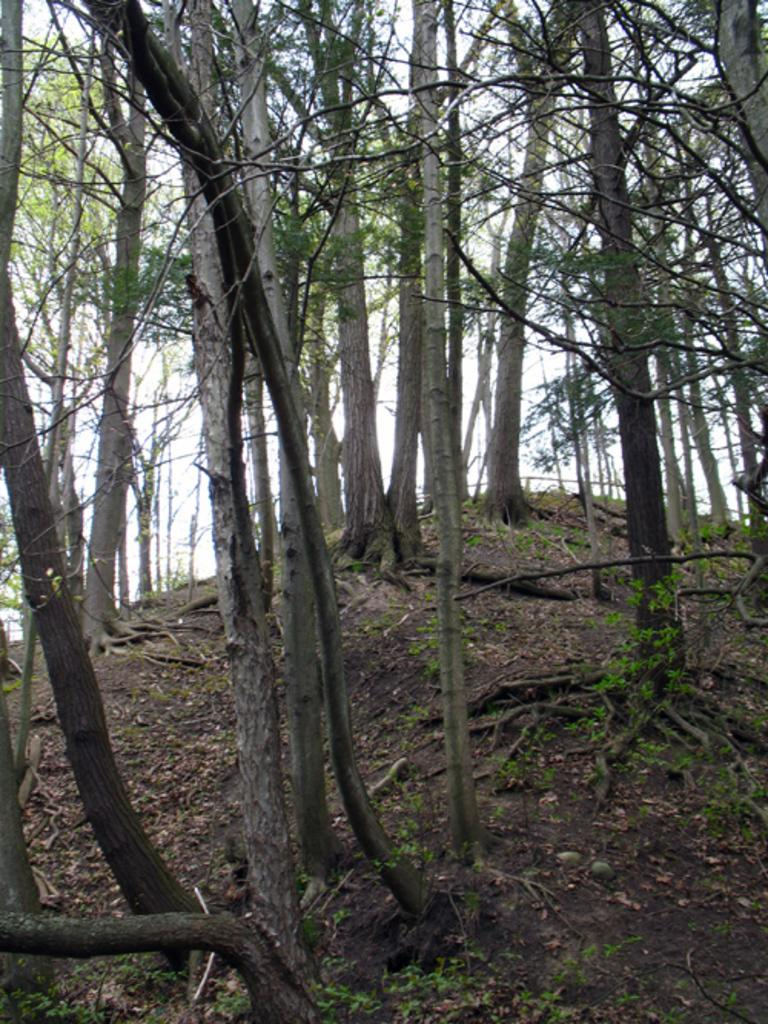What type of living organisms can be seen in the image? Plants and trees can be seen in the image. What part of the natural environment is visible in the image? The ground and the sky are visible in the image. What type of discovery can be seen being made in the image? There is no discovery being made in the image; it features plants, trees, the ground, and the sky. Where is the playground located in the image? There is no playground present in the image. 